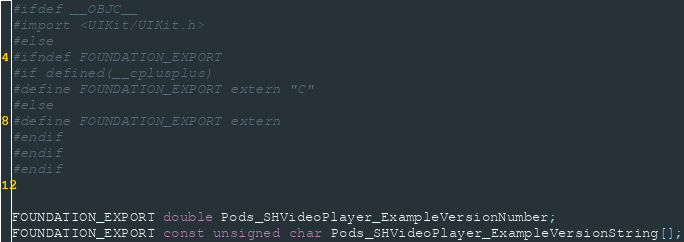<code> <loc_0><loc_0><loc_500><loc_500><_C_>#ifdef __OBJC__
#import <UIKit/UIKit.h>
#else
#ifndef FOUNDATION_EXPORT
#if defined(__cplusplus)
#define FOUNDATION_EXPORT extern "C"
#else
#define FOUNDATION_EXPORT extern
#endif
#endif
#endif


FOUNDATION_EXPORT double Pods_SHVideoPlayer_ExampleVersionNumber;
FOUNDATION_EXPORT const unsigned char Pods_SHVideoPlayer_ExampleVersionString[];

</code> 